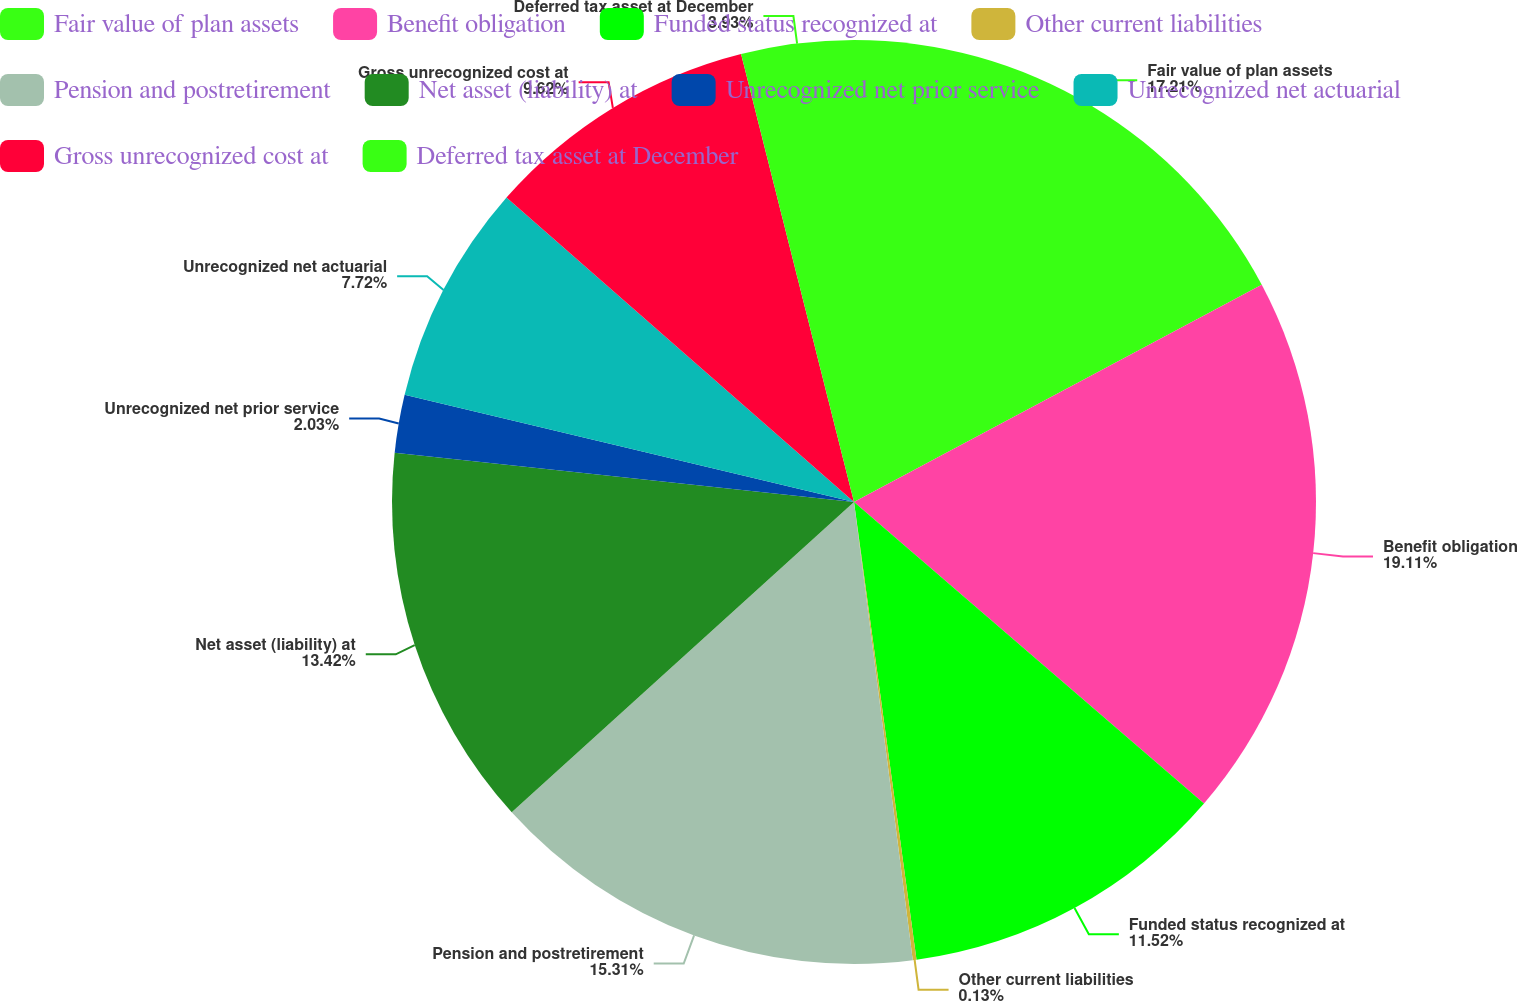Convert chart to OTSL. <chart><loc_0><loc_0><loc_500><loc_500><pie_chart><fcel>Fair value of plan assets<fcel>Benefit obligation<fcel>Funded status recognized at<fcel>Other current liabilities<fcel>Pension and postretirement<fcel>Net asset (liability) at<fcel>Unrecognized net prior service<fcel>Unrecognized net actuarial<fcel>Gross unrecognized cost at<fcel>Deferred tax asset at December<nl><fcel>17.21%<fcel>19.11%<fcel>11.52%<fcel>0.13%<fcel>15.31%<fcel>13.42%<fcel>2.03%<fcel>7.72%<fcel>9.62%<fcel>3.93%<nl></chart> 